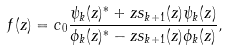Convert formula to latex. <formula><loc_0><loc_0><loc_500><loc_500>f ( z ) = c _ { 0 } \frac { \psi _ { k } ( z ) ^ { * } + z s _ { k + 1 } ( z ) \psi _ { k } ( z ) } { \phi _ { k } ( z ) ^ { * } - z s _ { k + 1 } ( z ) \phi _ { k } ( z ) } ,</formula> 